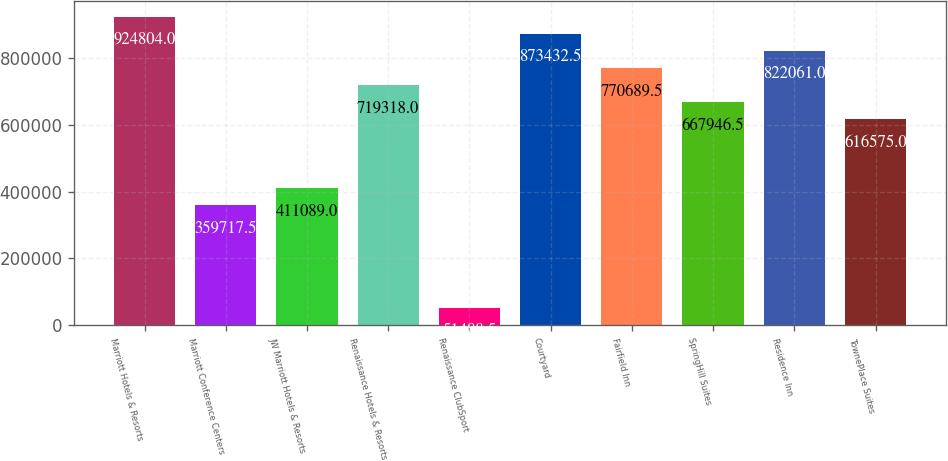<chart> <loc_0><loc_0><loc_500><loc_500><bar_chart><fcel>Marriott Hotels & Resorts<fcel>Marriott Conference Centers<fcel>JW Marriott Hotels & Resorts<fcel>Renaissance Hotels & Resorts<fcel>Renaissance ClubSport<fcel>Courtyard<fcel>Fairfield Inn<fcel>SpringHill Suites<fcel>Residence Inn<fcel>TownePlace Suites<nl><fcel>924804<fcel>359718<fcel>411089<fcel>719318<fcel>51488.5<fcel>873432<fcel>770690<fcel>667946<fcel>822061<fcel>616575<nl></chart> 